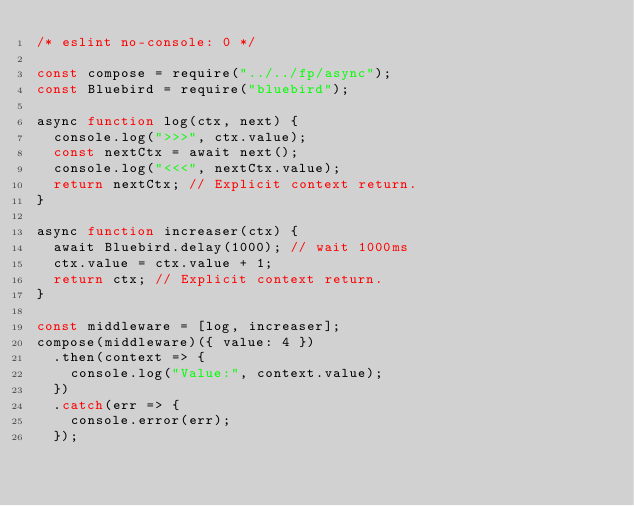<code> <loc_0><loc_0><loc_500><loc_500><_JavaScript_>/* eslint no-console: 0 */

const compose = require("../../fp/async");
const Bluebird = require("bluebird");

async function log(ctx, next) {
  console.log(">>>", ctx.value);
  const nextCtx = await next();
  console.log("<<<", nextCtx.value);
  return nextCtx; // Explicit context return.
}

async function increaser(ctx) {
  await Bluebird.delay(1000); // wait 1000ms
  ctx.value = ctx.value + 1;
  return ctx; // Explicit context return.
}

const middleware = [log, increaser];
compose(middleware)({ value: 4 })
  .then(context => {
    console.log("Value:", context.value);
  })
  .catch(err => {
    console.error(err);
  });
</code> 